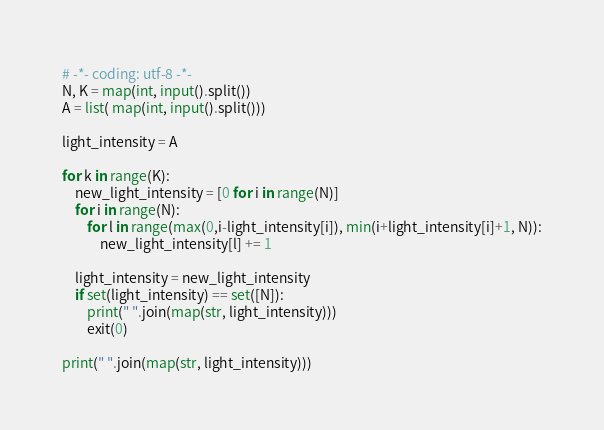Convert code to text. <code><loc_0><loc_0><loc_500><loc_500><_Python_># -*- coding: utf-8 -*-
N, K = map(int, input().split())
A = list( map(int, input().split()))

light_intensity = A

for k in range(K):
    new_light_intensity = [0 for i in range(N)]
    for i in range(N):
        for l in range(max(0,i-light_intensity[i]), min(i+light_intensity[i]+1, N)):
            new_light_intensity[l] += 1

    light_intensity = new_light_intensity
    if set(light_intensity) == set([N]):
        print(" ".join(map(str, light_intensity)))
        exit(0)

print(" ".join(map(str, light_intensity)))</code> 